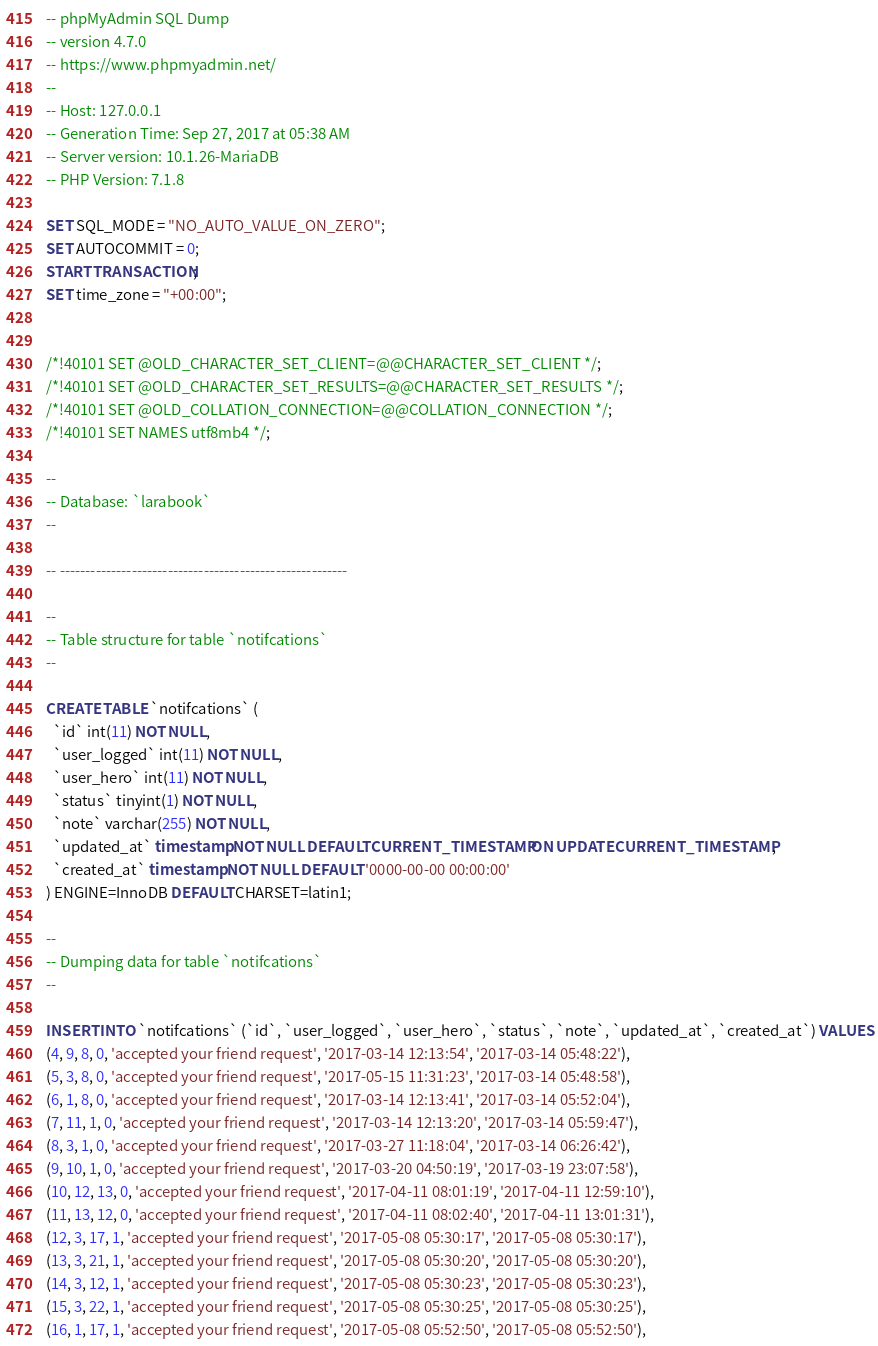<code> <loc_0><loc_0><loc_500><loc_500><_SQL_>-- phpMyAdmin SQL Dump
-- version 4.7.0
-- https://www.phpmyadmin.net/
--
-- Host: 127.0.0.1
-- Generation Time: Sep 27, 2017 at 05:38 AM
-- Server version: 10.1.26-MariaDB
-- PHP Version: 7.1.8

SET SQL_MODE = "NO_AUTO_VALUE_ON_ZERO";
SET AUTOCOMMIT = 0;
START TRANSACTION;
SET time_zone = "+00:00";


/*!40101 SET @OLD_CHARACTER_SET_CLIENT=@@CHARACTER_SET_CLIENT */;
/*!40101 SET @OLD_CHARACTER_SET_RESULTS=@@CHARACTER_SET_RESULTS */;
/*!40101 SET @OLD_COLLATION_CONNECTION=@@COLLATION_CONNECTION */;
/*!40101 SET NAMES utf8mb4 */;

--
-- Database: `larabook`
--

-- --------------------------------------------------------

--
-- Table structure for table `notifcations`
--

CREATE TABLE `notifcations` (
  `id` int(11) NOT NULL,
  `user_logged` int(11) NOT NULL,
  `user_hero` int(11) NOT NULL,
  `status` tinyint(1) NOT NULL,
  `note` varchar(255) NOT NULL,
  `updated_at` timestamp NOT NULL DEFAULT CURRENT_TIMESTAMP ON UPDATE CURRENT_TIMESTAMP,
  `created_at` timestamp NOT NULL DEFAULT '0000-00-00 00:00:00'
) ENGINE=InnoDB DEFAULT CHARSET=latin1;

--
-- Dumping data for table `notifcations`
--

INSERT INTO `notifcations` (`id`, `user_logged`, `user_hero`, `status`, `note`, `updated_at`, `created_at`) VALUES
(4, 9, 8, 0, 'accepted your friend request', '2017-03-14 12:13:54', '2017-03-14 05:48:22'),
(5, 3, 8, 0, 'accepted your friend request', '2017-05-15 11:31:23', '2017-03-14 05:48:58'),
(6, 1, 8, 0, 'accepted your friend request', '2017-03-14 12:13:41', '2017-03-14 05:52:04'),
(7, 11, 1, 0, 'accepted your friend request', '2017-03-14 12:13:20', '2017-03-14 05:59:47'),
(8, 3, 1, 0, 'accepted your friend request', '2017-03-27 11:18:04', '2017-03-14 06:26:42'),
(9, 10, 1, 0, 'accepted your friend request', '2017-03-20 04:50:19', '2017-03-19 23:07:58'),
(10, 12, 13, 0, 'accepted your friend request', '2017-04-11 08:01:19', '2017-04-11 12:59:10'),
(11, 13, 12, 0, 'accepted your friend request', '2017-04-11 08:02:40', '2017-04-11 13:01:31'),
(12, 3, 17, 1, 'accepted your friend request', '2017-05-08 05:30:17', '2017-05-08 05:30:17'),
(13, 3, 21, 1, 'accepted your friend request', '2017-05-08 05:30:20', '2017-05-08 05:30:20'),
(14, 3, 12, 1, 'accepted your friend request', '2017-05-08 05:30:23', '2017-05-08 05:30:23'),
(15, 3, 22, 1, 'accepted your friend request', '2017-05-08 05:30:25', '2017-05-08 05:30:25'),
(16, 1, 17, 1, 'accepted your friend request', '2017-05-08 05:52:50', '2017-05-08 05:52:50'),</code> 